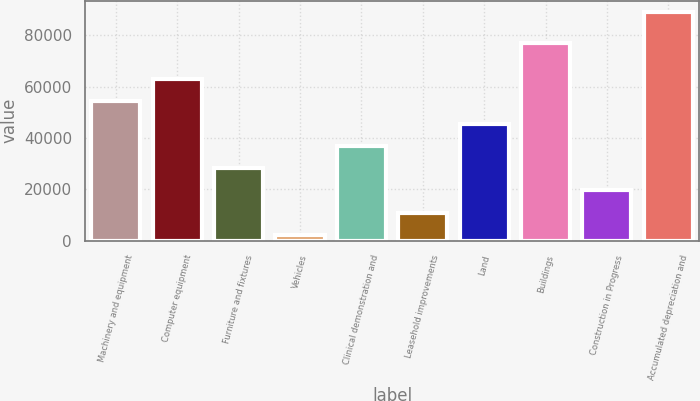Convert chart. <chart><loc_0><loc_0><loc_500><loc_500><bar_chart><fcel>Machinery and equipment<fcel>Computer equipment<fcel>Furniture and fixtures<fcel>Vehicles<fcel>Clinical demonstration and<fcel>Leasehold improvements<fcel>Land<fcel>Buildings<fcel>Construction in Progress<fcel>Accumulated depreciation and<nl><fcel>54288.4<fcel>62958.8<fcel>28277.2<fcel>2266<fcel>36947.6<fcel>10936.4<fcel>45618<fcel>77101<fcel>19606.8<fcel>88970<nl></chart> 